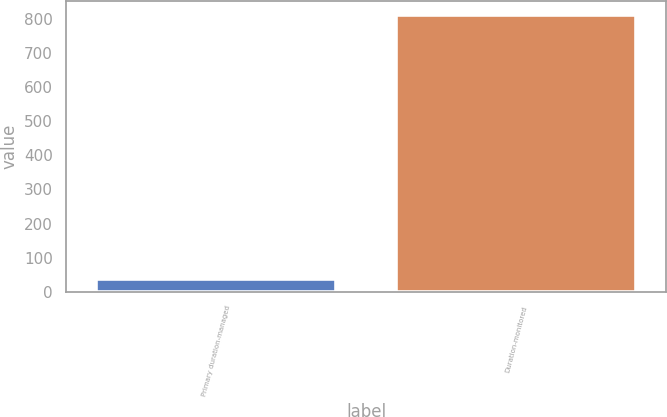<chart> <loc_0><loc_0><loc_500><loc_500><bar_chart><fcel>Primary duration-managed<fcel>Duration-monitored<nl><fcel>36.3<fcel>811.5<nl></chart> 